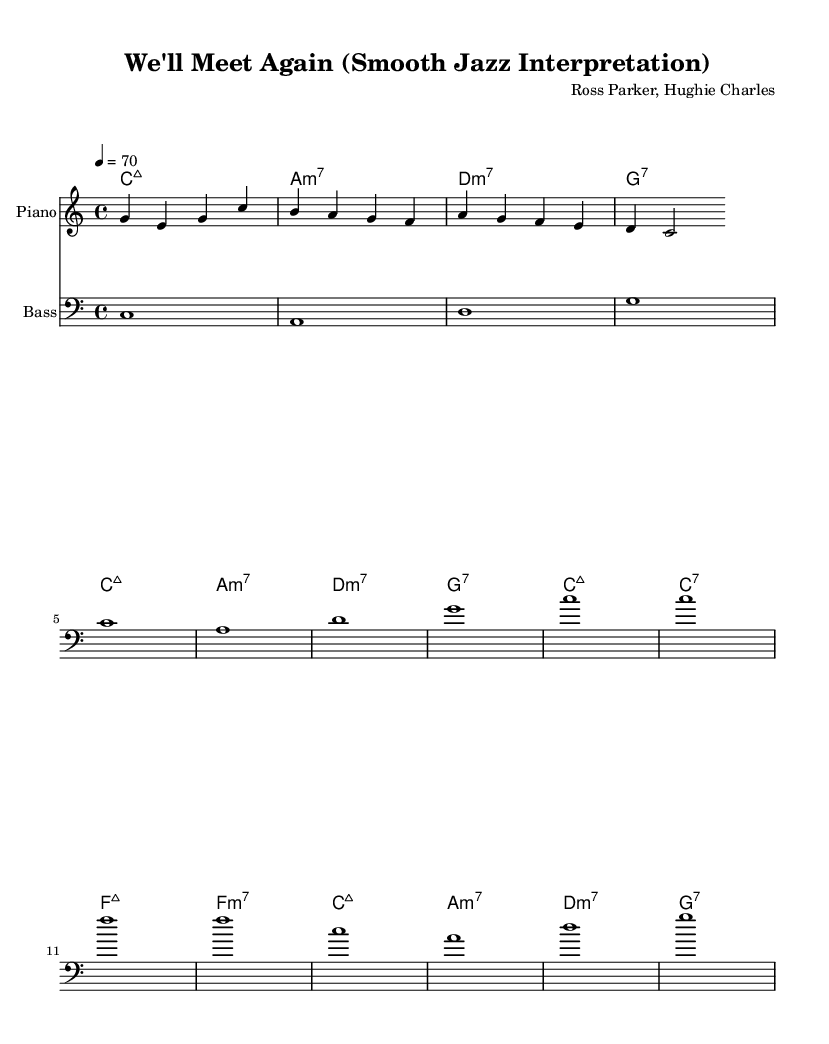What is the key signature of this music? The key signature is C major, depicted at the beginning of the score with no sharps or flats.
Answer: C major What is the time signature of this music? The time signature is indicated at the beginning of the score, showing 4 beats per measure.
Answer: 4/4 What is the tempo marking of the piece? The tempo marking of the piece is 70 beats per minute, specified in the tempo line at the start.
Answer: 70 How many measures are in the piece? By counting the distinct sets of chords and measures in the score, there are 8 measures total.
Answer: 8 What is the highest note in the melody? The highest note in the melody is G, which appears towards the start of the melody line.
Answer: G What is the main type of chords used in the chord progression? The main type of chords used in the chord progression includes major seventh and minor seventh chords, common in jazz.
Answer: Major seventh and minor seventh Which instrument plays the melody? The instrument designated to play the melody, as specified in the score, is the piano.
Answer: Piano 